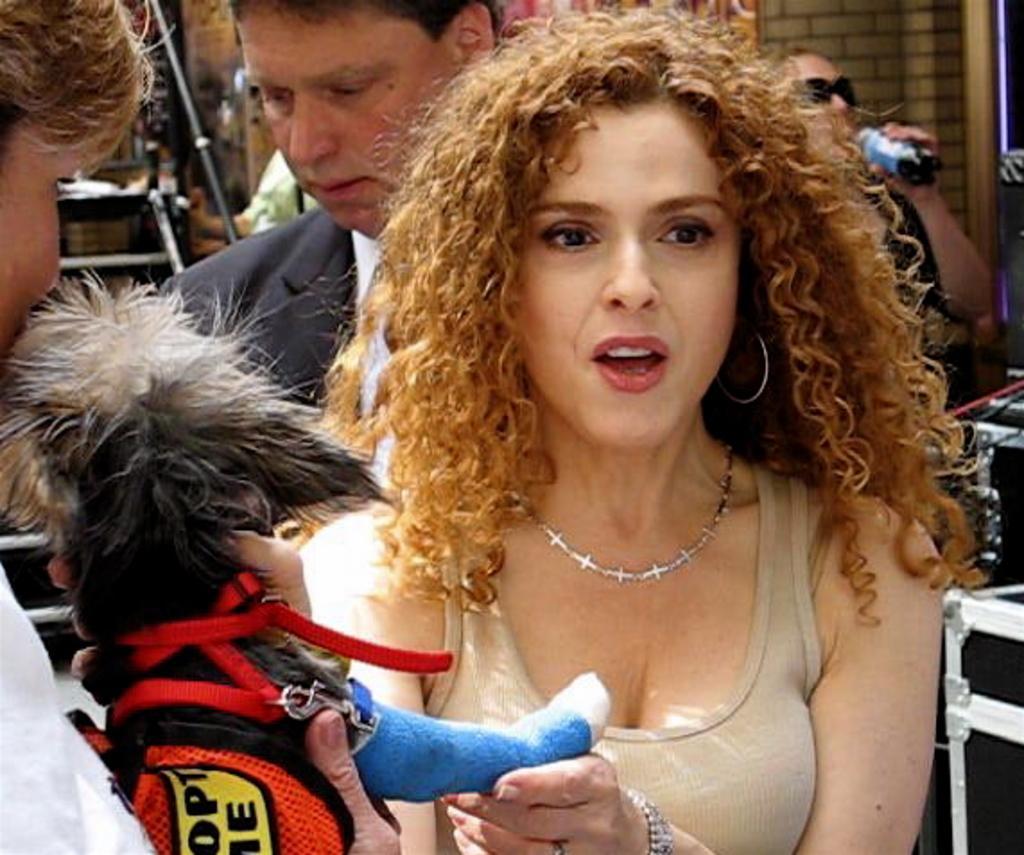In one or two sentences, can you explain what this image depicts? Here we can see a woman holding a dog. In the background we can see persons and a wall. 